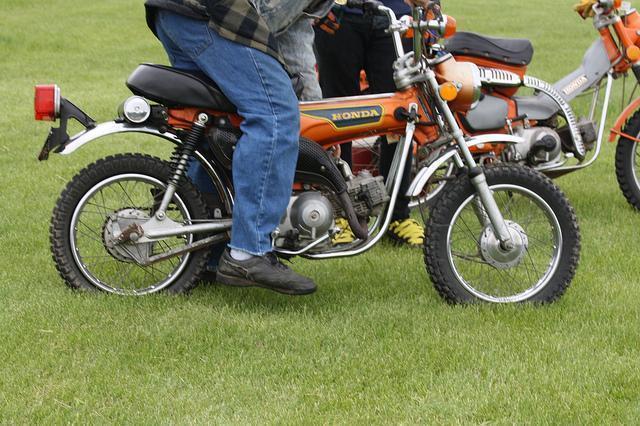What type of road are the small motorcycles created for?
Select the correct answer and articulate reasoning with the following format: 'Answer: answer
Rationale: rationale.'
Options: Roadways, highways, bike lanes, trails. Answer: trails.
Rationale: The tires have large tread. large tread can find better traction in the dirt. 